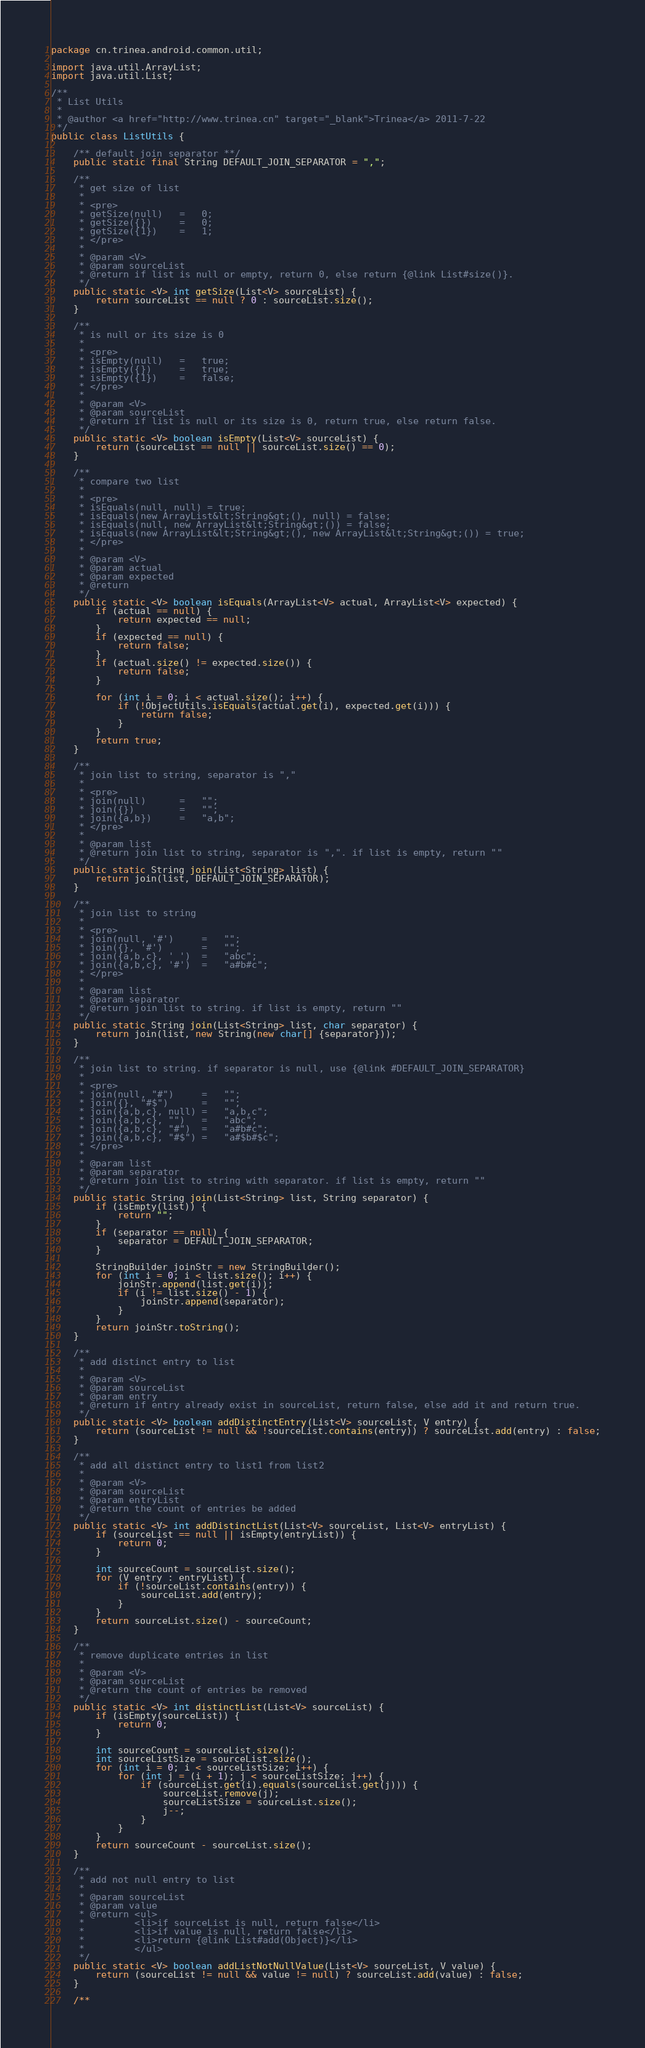Convert code to text. <code><loc_0><loc_0><loc_500><loc_500><_Java_>package cn.trinea.android.common.util;

import java.util.ArrayList;
import java.util.List;

/**
 * List Utils
 * 
 * @author <a href="http://www.trinea.cn" target="_blank">Trinea</a> 2011-7-22
 */
public class ListUtils {

    /** default join separator **/
    public static final String DEFAULT_JOIN_SEPARATOR = ",";

    /**
     * get size of list
     * 
     * <pre>
     * getSize(null)   =   0;
     * getSize({})     =   0;
     * getSize({1})    =   1;
     * </pre>
     * 
     * @param <V>
     * @param sourceList
     * @return if list is null or empty, return 0, else return {@link List#size()}.
     */
    public static <V> int getSize(List<V> sourceList) {
        return sourceList == null ? 0 : sourceList.size();
    }

    /**
     * is null or its size is 0
     * 
     * <pre>
     * isEmpty(null)   =   true;
     * isEmpty({})     =   true;
     * isEmpty({1})    =   false;
     * </pre>
     * 
     * @param <V>
     * @param sourceList
     * @return if list is null or its size is 0, return true, else return false.
     */
    public static <V> boolean isEmpty(List<V> sourceList) {
        return (sourceList == null || sourceList.size() == 0);
    }

    /**
     * compare two list
     * 
     * <pre>
     * isEquals(null, null) = true;
     * isEquals(new ArrayList&lt;String&gt;(), null) = false;
     * isEquals(null, new ArrayList&lt;String&gt;()) = false;
     * isEquals(new ArrayList&lt;String&gt;(), new ArrayList&lt;String&gt;()) = true;
     * </pre>
     * 
     * @param <V>
     * @param actual
     * @param expected
     * @return
     */
    public static <V> boolean isEquals(ArrayList<V> actual, ArrayList<V> expected) {
        if (actual == null) {
            return expected == null;
        }
        if (expected == null) {
            return false;
        }
        if (actual.size() != expected.size()) {
            return false;
        }

        for (int i = 0; i < actual.size(); i++) {
            if (!ObjectUtils.isEquals(actual.get(i), expected.get(i))) {
                return false;
            }
        }
        return true;
    }

    /**
     * join list to string, separator is ","
     * 
     * <pre>
     * join(null)      =   "";
     * join({})        =   "";
     * join({a,b})     =   "a,b";
     * </pre>
     * 
     * @param list
     * @return join list to string, separator is ",". if list is empty, return ""
     */
    public static String join(List<String> list) {
        return join(list, DEFAULT_JOIN_SEPARATOR);
    }

    /**
     * join list to string
     * 
     * <pre>
     * join(null, '#')     =   "";
     * join({}, '#')       =   "";
     * join({a,b,c}, ' ')  =   "abc";
     * join({a,b,c}, '#')  =   "a#b#c";
     * </pre>
     * 
     * @param list
     * @param separator
     * @return join list to string. if list is empty, return ""
     */
    public static String join(List<String> list, char separator) {
        return join(list, new String(new char[] {separator}));
    }

    /**
     * join list to string. if separator is null, use {@link #DEFAULT_JOIN_SEPARATOR}
     * 
     * <pre>
     * join(null, "#")     =   "";
     * join({}, "#$")      =   "";
     * join({a,b,c}, null) =   "a,b,c";
     * join({a,b,c}, "")   =   "abc";
     * join({a,b,c}, "#")  =   "a#b#c";
     * join({a,b,c}, "#$") =   "a#$b#$c";
     * </pre>
     * 
     * @param list
     * @param separator
     * @return join list to string with separator. if list is empty, return ""
     */
    public static String join(List<String> list, String separator) {
        if (isEmpty(list)) {
            return "";
        }
        if (separator == null) {
            separator = DEFAULT_JOIN_SEPARATOR;
        }

        StringBuilder joinStr = new StringBuilder();
        for (int i = 0; i < list.size(); i++) {
            joinStr.append(list.get(i));
            if (i != list.size() - 1) {
                joinStr.append(separator);
            }
        }
        return joinStr.toString();
    }

    /**
     * add distinct entry to list
     * 
     * @param <V>
     * @param sourceList
     * @param entry
     * @return if entry already exist in sourceList, return false, else add it and return true.
     */
    public static <V> boolean addDistinctEntry(List<V> sourceList, V entry) {
        return (sourceList != null && !sourceList.contains(entry)) ? sourceList.add(entry) : false;
    }

    /**
     * add all distinct entry to list1 from list2
     * 
     * @param <V>
     * @param sourceList
     * @param entryList
     * @return the count of entries be added
     */
    public static <V> int addDistinctList(List<V> sourceList, List<V> entryList) {
        if (sourceList == null || isEmpty(entryList)) {
            return 0;
        }

        int sourceCount = sourceList.size();
        for (V entry : entryList) {
            if (!sourceList.contains(entry)) {
                sourceList.add(entry);
            }
        }
        return sourceList.size() - sourceCount;
    }

    /**
     * remove duplicate entries in list
     * 
     * @param <V>
     * @param sourceList
     * @return the count of entries be removed
     */
    public static <V> int distinctList(List<V> sourceList) {
        if (isEmpty(sourceList)) {
            return 0;
        }

        int sourceCount = sourceList.size();
        int sourceListSize = sourceList.size();
        for (int i = 0; i < sourceListSize; i++) {
            for (int j = (i + 1); j < sourceListSize; j++) {
                if (sourceList.get(i).equals(sourceList.get(j))) {
                    sourceList.remove(j);
                    sourceListSize = sourceList.size();
                    j--;
                }
            }
        }
        return sourceCount - sourceList.size();
    }

    /**
     * add not null entry to list
     * 
     * @param sourceList
     * @param value
     * @return <ul>
     *         <li>if sourceList is null, return false</li>
     *         <li>if value is null, return false</li>
     *         <li>return {@link List#add(Object)}</li>
     *         </ul>
     */
    public static <V> boolean addListNotNullValue(List<V> sourceList, V value) {
        return (sourceList != null && value != null) ? sourceList.add(value) : false;
    }

    /**</code> 